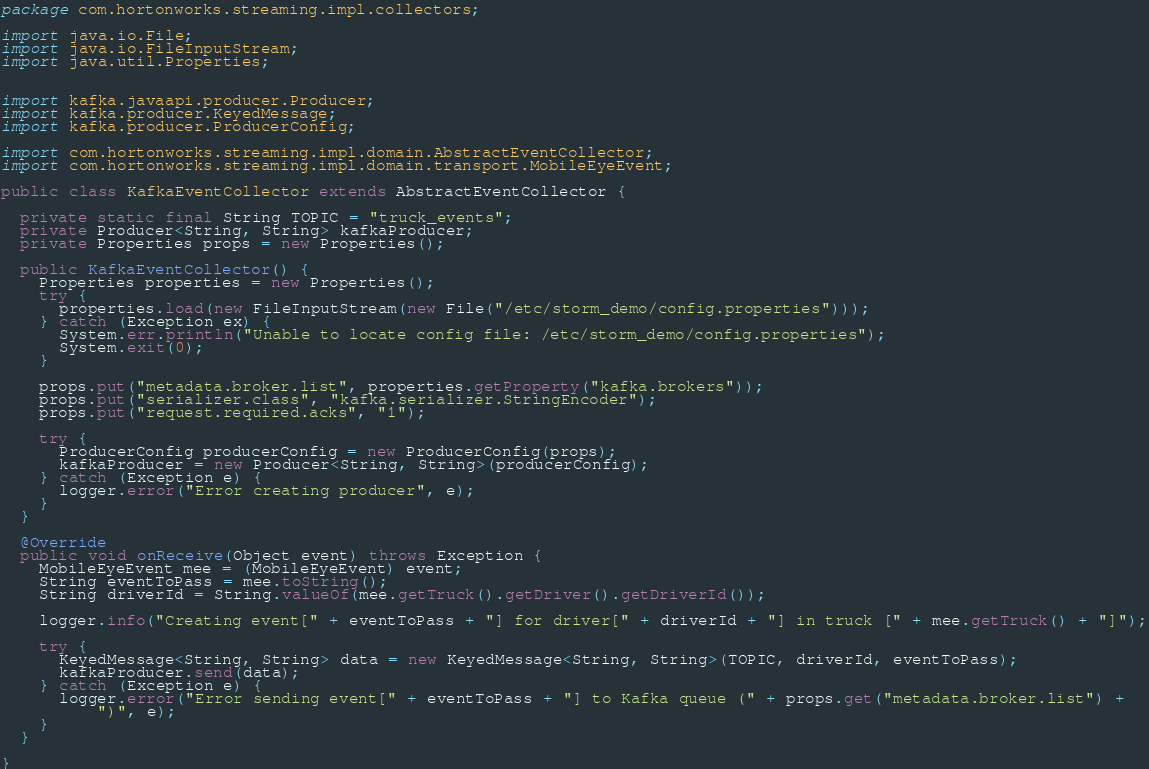<code> <loc_0><loc_0><loc_500><loc_500><_Java_>package com.hortonworks.streaming.impl.collectors;

import java.io.File;
import java.io.FileInputStream;
import java.util.Properties;


import kafka.javaapi.producer.Producer;
import kafka.producer.KeyedMessage;
import kafka.producer.ProducerConfig;

import com.hortonworks.streaming.impl.domain.AbstractEventCollector;
import com.hortonworks.streaming.impl.domain.transport.MobileEyeEvent;

public class KafkaEventCollector extends AbstractEventCollector {

  private static final String TOPIC = "truck_events";
  private Producer<String, String> kafkaProducer;
  private Properties props = new Properties();

  public KafkaEventCollector() {
    Properties properties = new Properties();
    try {
      properties.load(new FileInputStream(new File("/etc/storm_demo/config.properties")));
    } catch (Exception ex) {
      System.err.println("Unable to locate config file: /etc/storm_demo/config.properties");
      System.exit(0);
    }

    props.put("metadata.broker.list", properties.getProperty("kafka.brokers"));
    props.put("serializer.class", "kafka.serializer.StringEncoder");
    props.put("request.required.acks", "1");

    try {
      ProducerConfig producerConfig = new ProducerConfig(props);
      kafkaProducer = new Producer<String, String>(producerConfig);
    } catch (Exception e) {
      logger.error("Error creating producer", e);
    }
  }

  @Override
  public void onReceive(Object event) throws Exception {
    MobileEyeEvent mee = (MobileEyeEvent) event;
    String eventToPass = mee.toString();
    String driverId = String.valueOf(mee.getTruck().getDriver().getDriverId());

    logger.info("Creating event[" + eventToPass + "] for driver[" + driverId + "] in truck [" + mee.getTruck() + "]");

    try {
      KeyedMessage<String, String> data = new KeyedMessage<String, String>(TOPIC, driverId, eventToPass);
      kafkaProducer.send(data);
    } catch (Exception e) {
      logger.error("Error sending event[" + eventToPass + "] to Kafka queue (" + props.get("metadata.broker.list") +
          ")", e);
    }
  }

}
</code> 